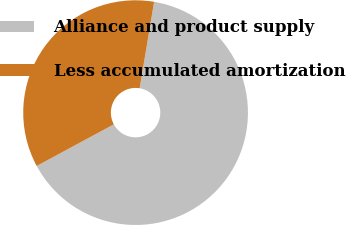<chart> <loc_0><loc_0><loc_500><loc_500><pie_chart><fcel>Alliance and product supply<fcel>Less accumulated amortization<nl><fcel>64.49%<fcel>35.51%<nl></chart> 